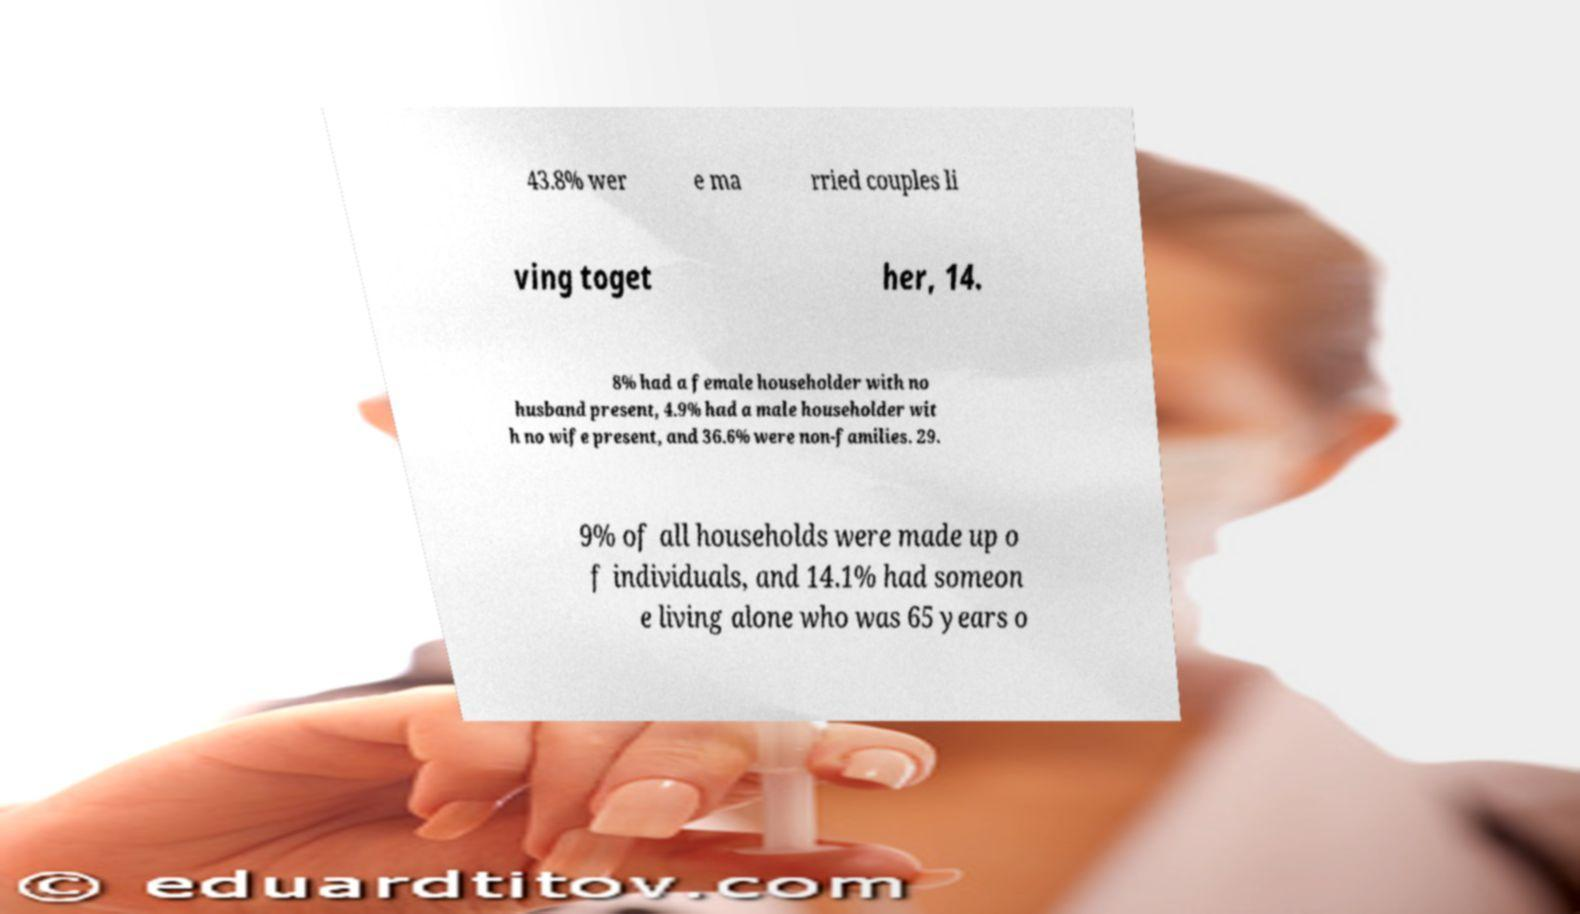Can you read and provide the text displayed in the image?This photo seems to have some interesting text. Can you extract and type it out for me? 43.8% wer e ma rried couples li ving toget her, 14. 8% had a female householder with no husband present, 4.9% had a male householder wit h no wife present, and 36.6% were non-families. 29. 9% of all households were made up o f individuals, and 14.1% had someon e living alone who was 65 years o 